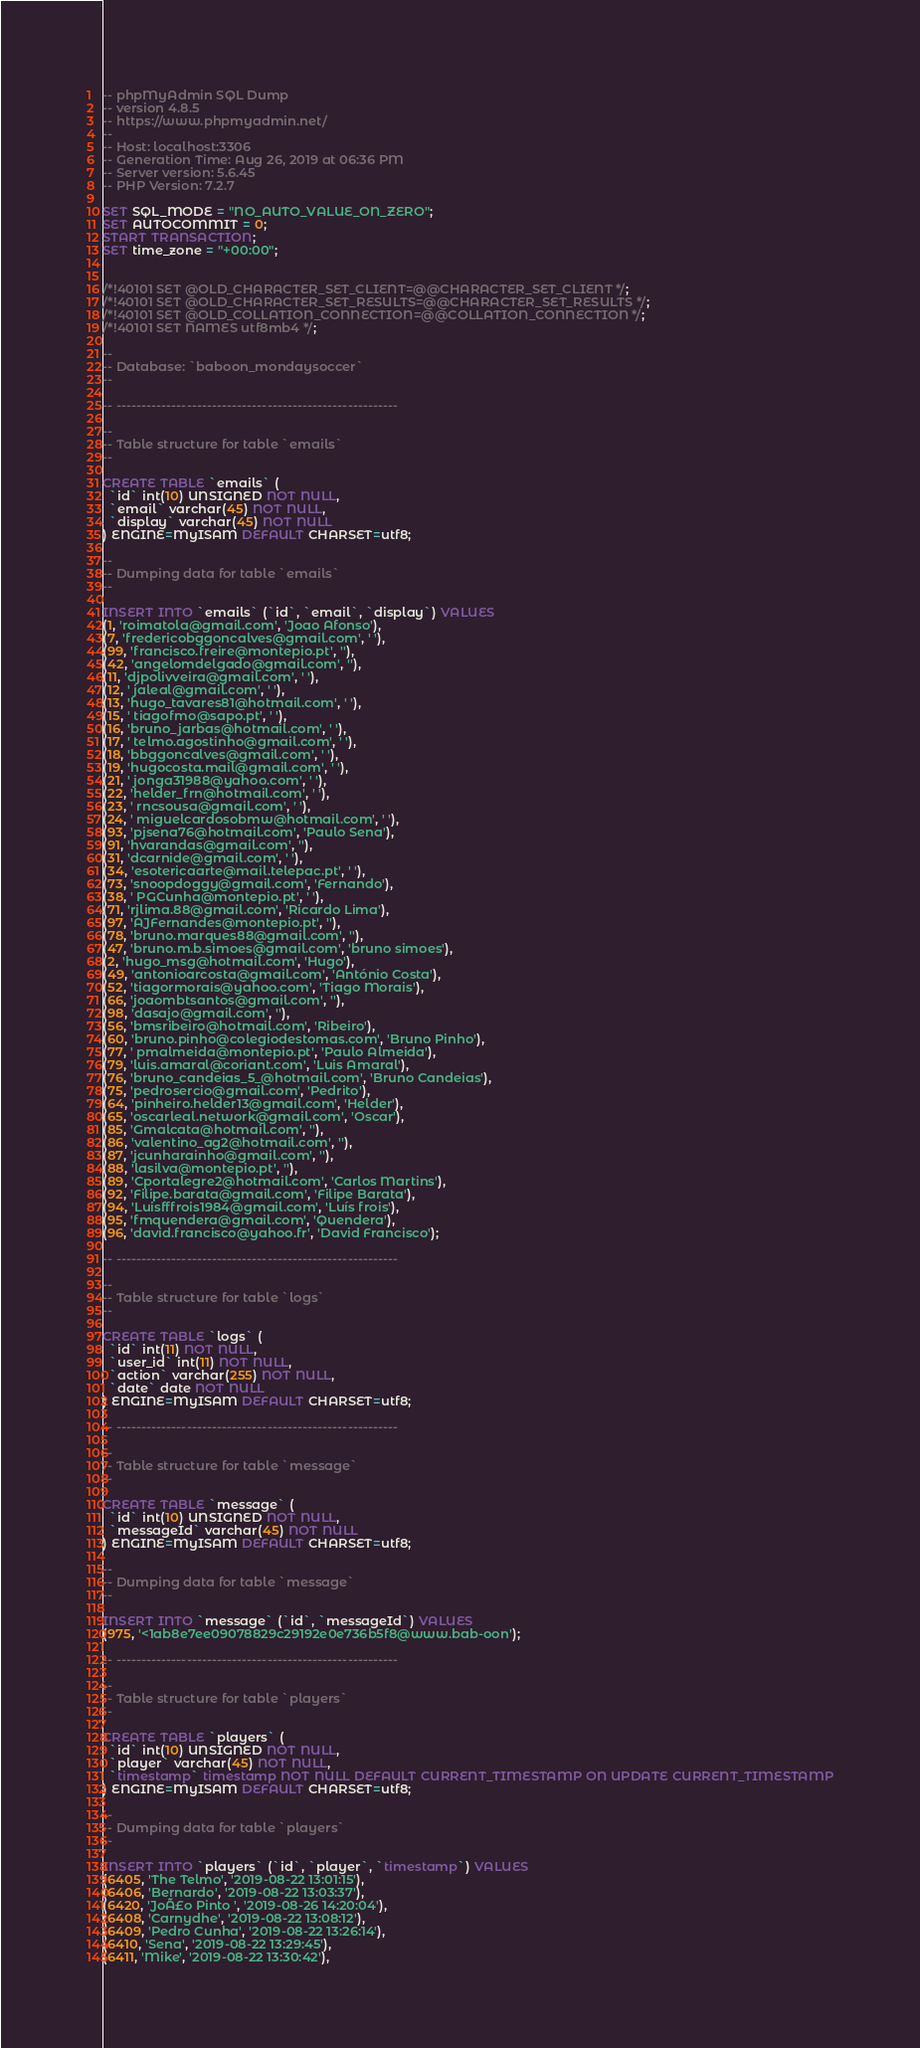<code> <loc_0><loc_0><loc_500><loc_500><_SQL_>-- phpMyAdmin SQL Dump
-- version 4.8.5
-- https://www.phpmyadmin.net/
--
-- Host: localhost:3306
-- Generation Time: Aug 26, 2019 at 06:36 PM
-- Server version: 5.6.45
-- PHP Version: 7.2.7

SET SQL_MODE = "NO_AUTO_VALUE_ON_ZERO";
SET AUTOCOMMIT = 0;
START TRANSACTION;
SET time_zone = "+00:00";


/*!40101 SET @OLD_CHARACTER_SET_CLIENT=@@CHARACTER_SET_CLIENT */;
/*!40101 SET @OLD_CHARACTER_SET_RESULTS=@@CHARACTER_SET_RESULTS */;
/*!40101 SET @OLD_COLLATION_CONNECTION=@@COLLATION_CONNECTION */;
/*!40101 SET NAMES utf8mb4 */;

--
-- Database: `baboon_mondaysoccer`
--

-- --------------------------------------------------------

--
-- Table structure for table `emails`
--

CREATE TABLE `emails` (
  `id` int(10) UNSIGNED NOT NULL,
  `email` varchar(45) NOT NULL,
  `display` varchar(45) NOT NULL
) ENGINE=MyISAM DEFAULT CHARSET=utf8;

--
-- Dumping data for table `emails`
--

INSERT INTO `emails` (`id`, `email`, `display`) VALUES
(1, 'roimatola@gmail.com', 'Joao Afonso'),
(7, 'fredericobggoncalves@gmail.com', ' '),
(99, 'francisco.freire@montepio.pt', ''),
(42, 'angelomdelgado@gmail.com', ''),
(11, 'djpolivveira@gmail.com', ' '),
(12, ' jaleal@gmail.com', ' '),
(13, 'hugo_tavares81@hotmail.com', ' '),
(15, ' tiagofmo@sapo.pt', ' '),
(16, 'bruno_jarbas@hotmail.com', ' '),
(17, ' telmo.agostinho@gmail.com', ' '),
(18, 'bbggoncalves@gmail.com', ' '),
(19, 'hugocosta.mail@gmail.com', ' '),
(21, ' jonga31988@yahoo.com', ' '),
(22, 'helder_frn@hotmail.com', ' '),
(23, ' rncsousa@gmail.com', ' '),
(24, ' miguelcardosobmw@hotmail.com', ' '),
(93, 'pjsena76@hotmail.com', 'Paulo Sena'),
(91, 'hvarandas@gmail.com', ''),
(31, 'dcarnide@gmail.com', ' '),
(34, 'esotericaarte@mail.telepac.pt', ' '),
(73, 'snoopdoggy@gmail.com', 'Fernando'),
(38, ' PGCunha@montepio.pt', ' '),
(71, 'rjlima.88@gmail.com', 'Ricardo Lima'),
(97, 'AJFernandes@montepio.pt', ''),
(78, 'bruno.marques88@gmail.com', ''),
(47, 'bruno.m.b.simoes@gmail.com', 'bruno simoes'),
(2, 'hugo_msg@hotmail.com', 'Hugo'),
(49, 'antonioarcosta@gmail.com', 'António Costa'),
(52, 'tiagormorais@yahoo.com', 'Tiago Morais'),
(66, 'joaombtsantos@gmail.com', ''),
(98, 'dasajo@gmail.com', ''),
(56, 'bmsribeiro@hotmail.com', 'Ribeiro'),
(60, 'bruno.pinho@colegiodestomas.com', 'Bruno Pinho'),
(77, ' pmalmeida@montepio.pt', 'Paulo Almeida'),
(79, 'luis.amaral@coriant.com', 'Luis Amaral'),
(76, 'bruno_candeias_5_@hotmail.com', 'Bruno Candeias'),
(75, 'pedrosercio@gmail.com', 'Pedrito'),
(64, 'pinheiro.helder13@gmail.com', 'Helder'),
(65, 'oscarleal.network@gmail.com', 'Oscar'),
(85, 'Gmalcata@hotmail.com', ''),
(86, 'valentino_ag2@hotmail.com', ''),
(87, 'jcunharainho@gmail.com', ''),
(88, 'lasilva@montepio.pt', ''),
(89, 'Cportalegre2@hotmail.com', 'Carlos Martins'),
(92, 'Filipe.barata@gmail.com', 'Filipe Barata'),
(94, 'Luisfffrois1984@gmail.com', 'Luís frois'),
(95, 'fmquendera@gmail.com', 'Quendera'),
(96, 'david.francisco@yahoo.fr', 'David Francisco');

-- --------------------------------------------------------

--
-- Table structure for table `logs`
--

CREATE TABLE `logs` (
  `id` int(11) NOT NULL,
  `user_id` int(11) NOT NULL,
  `action` varchar(255) NOT NULL,
  `date` date NOT NULL
) ENGINE=MyISAM DEFAULT CHARSET=utf8;

-- --------------------------------------------------------

--
-- Table structure for table `message`
--

CREATE TABLE `message` (
  `id` int(10) UNSIGNED NOT NULL,
  `messageId` varchar(45) NOT NULL
) ENGINE=MyISAM DEFAULT CHARSET=utf8;

--
-- Dumping data for table `message`
--

INSERT INTO `message` (`id`, `messageId`) VALUES
(975, '<1ab8e7ee09078829c29192e0e736b5f8@www.bab-oon');

-- --------------------------------------------------------

--
-- Table structure for table `players`
--

CREATE TABLE `players` (
  `id` int(10) UNSIGNED NOT NULL,
  `player` varchar(45) NOT NULL,
  `timestamp` timestamp NOT NULL DEFAULT CURRENT_TIMESTAMP ON UPDATE CURRENT_TIMESTAMP
) ENGINE=MyISAM DEFAULT CHARSET=utf8;

--
-- Dumping data for table `players`
--

INSERT INTO `players` (`id`, `player`, `timestamp`) VALUES
(6405, 'The Telmo', '2019-08-22 13:01:15'),
(6406, 'Bernardo', '2019-08-22 13:03:37'),
(6420, 'JoÃ£o Pinto ', '2019-08-26 14:20:04'),
(6408, 'Carnydhe', '2019-08-22 13:08:12'),
(6409, 'Pedro Cunha', '2019-08-22 13:26:14'),
(6410, 'Sena', '2019-08-22 13:29:45'),
(6411, 'Mike', '2019-08-22 13:30:42'),</code> 